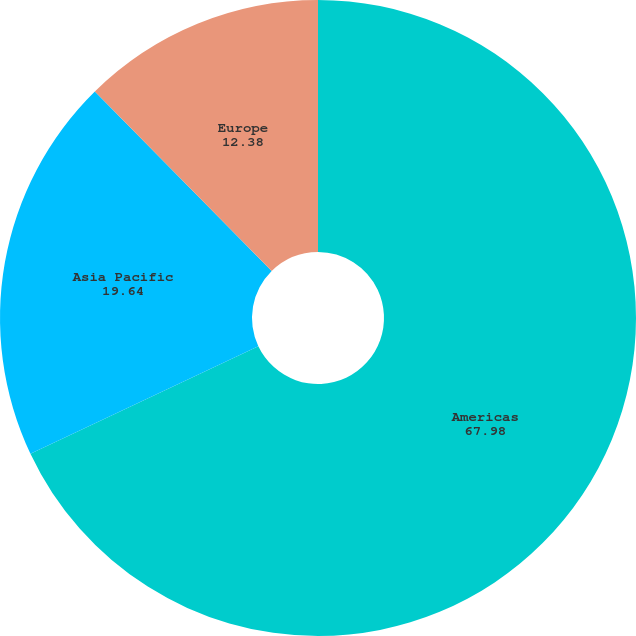Convert chart to OTSL. <chart><loc_0><loc_0><loc_500><loc_500><pie_chart><fcel>Americas<fcel>Asia Pacific<fcel>Europe<nl><fcel>67.98%<fcel>19.64%<fcel>12.38%<nl></chart> 